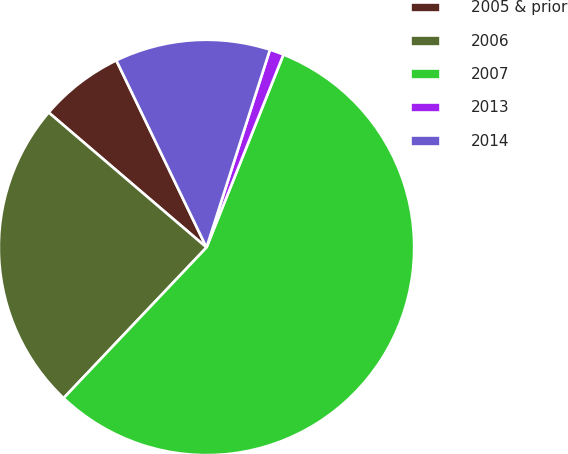Convert chart. <chart><loc_0><loc_0><loc_500><loc_500><pie_chart><fcel>2005 & prior<fcel>2006<fcel>2007<fcel>2013<fcel>2014<nl><fcel>6.59%<fcel>24.18%<fcel>56.04%<fcel>1.1%<fcel>12.09%<nl></chart> 